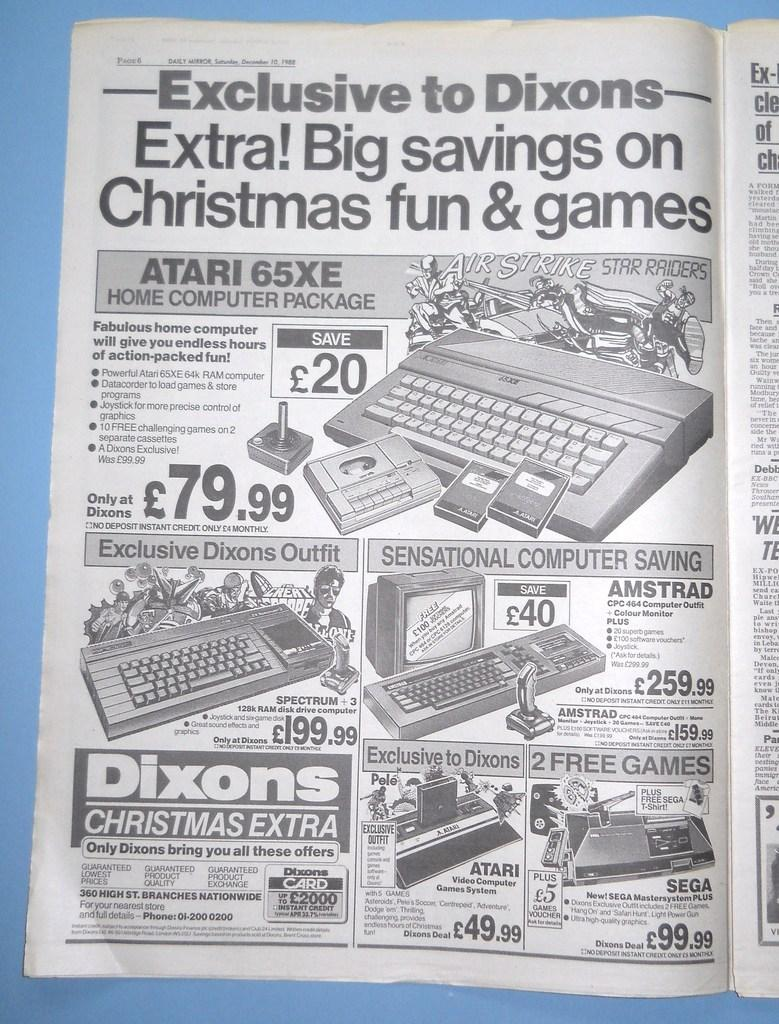<image>
Share a concise interpretation of the image provided. an open newspaper to an ad Exclusive to Dixons for Christmas 